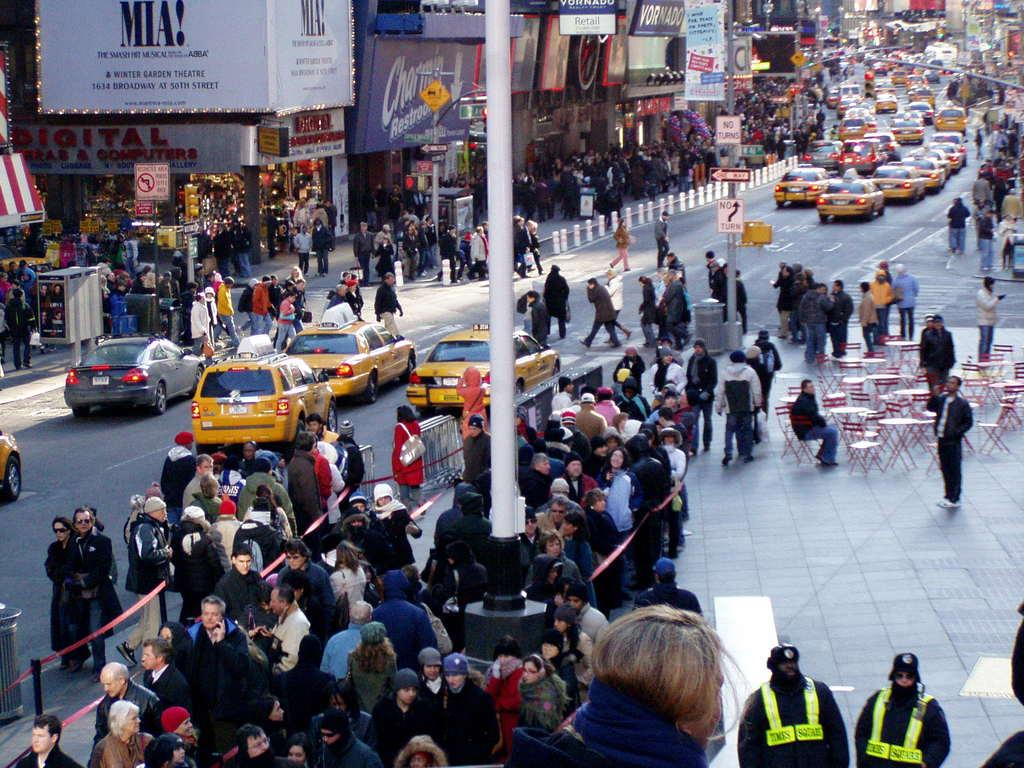Provide a one-sentence caption for the provided image. a Mia advertisement that is outside in a busy city. 